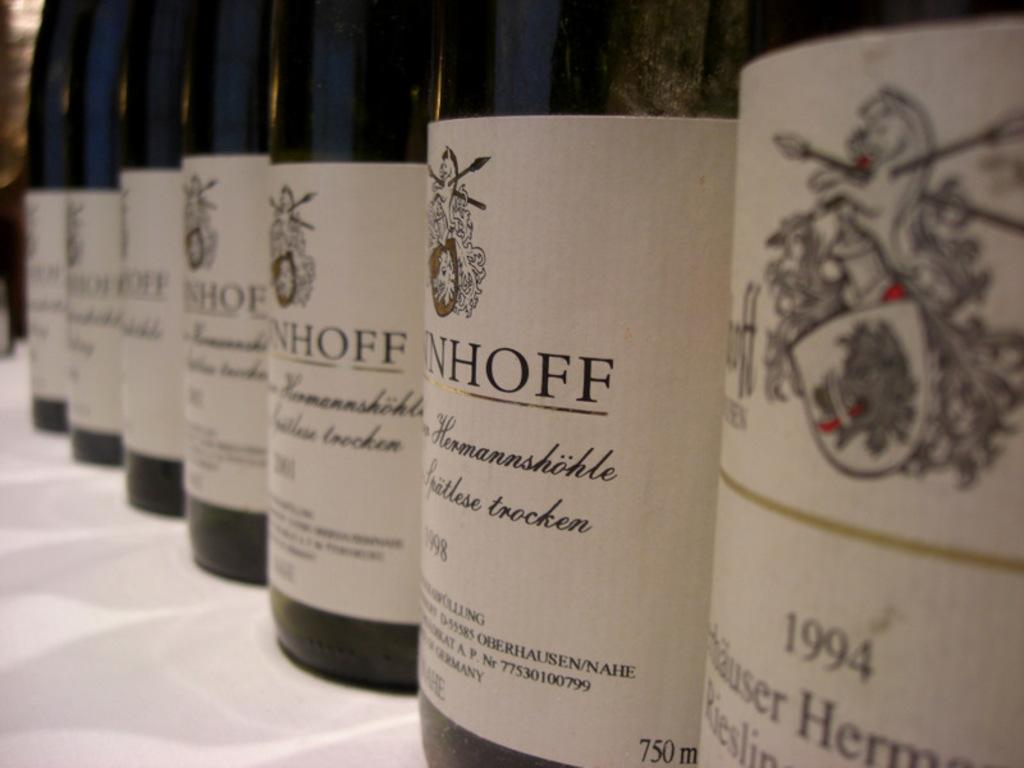<image>
Provide a brief description of the given image. Many bottles of wine are lined up, including one of 1994 and another from 1998. 